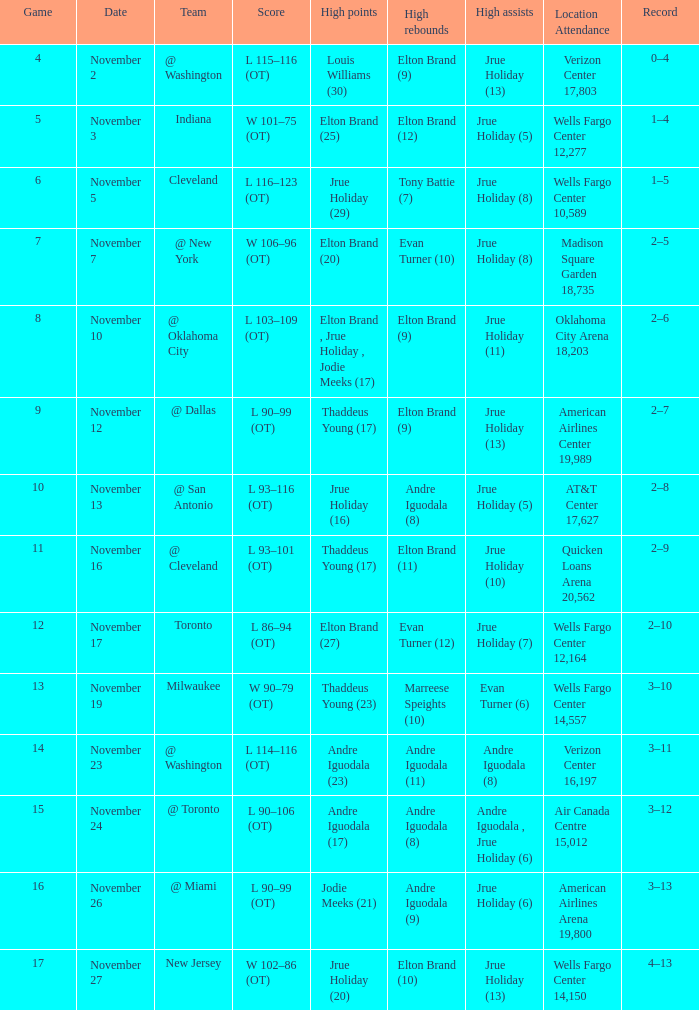What is the score for the game with the record of 3–12? L 90–106 (OT). 